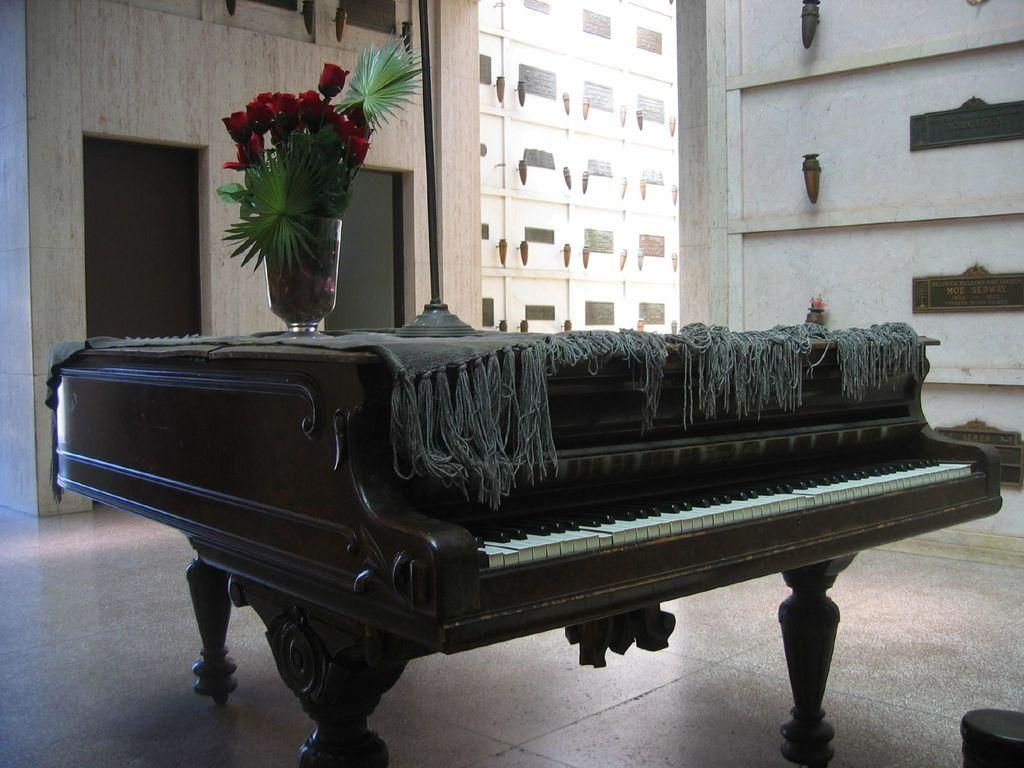What musical instrument is present in the image? There is a piano in the image. What is placed on top of the piano? There is a flower vase on the piano. What can be seen in the background of the image? There is a building, a wall, and a door in the background of the image. Where is the pig located in the image? There is no pig present in the image. 